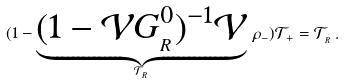Convert formula to latex. <formula><loc_0><loc_0><loc_500><loc_500>( 1 - \underbrace { ( 1 - \mathcal { V } G _ { _ { R } } ^ { 0 } ) ^ { - 1 } \mathcal { V } } _ { \mathcal { T } _ { _ { R } } } \, \rho _ { - } ) \mathcal { T } _ { + } = \mathcal { T } _ { _ { R } } \, .</formula> 